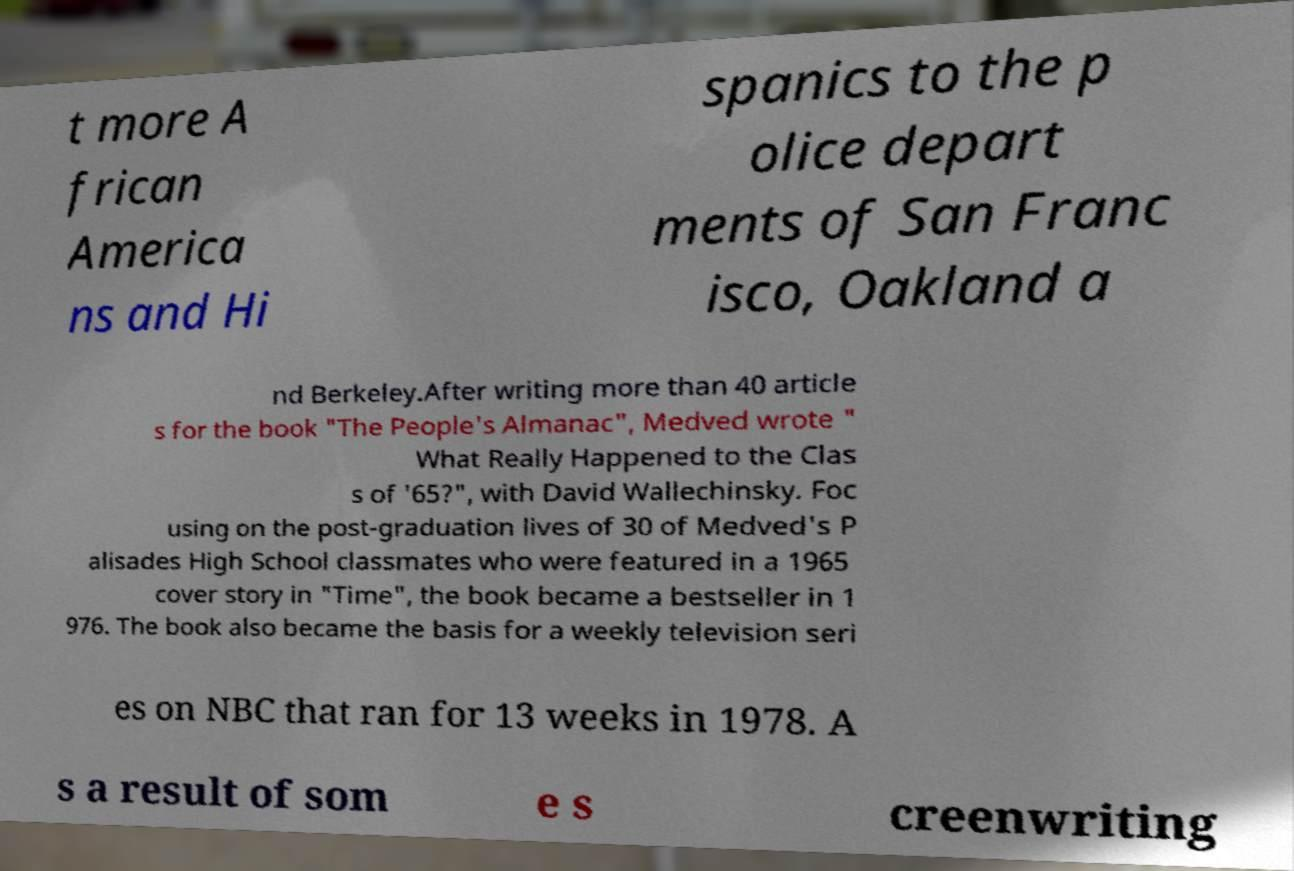Can you read and provide the text displayed in the image?This photo seems to have some interesting text. Can you extract and type it out for me? t more A frican America ns and Hi spanics to the p olice depart ments of San Franc isco, Oakland a nd Berkeley.After writing more than 40 article s for the book "The People's Almanac", Medved wrote " What Really Happened to the Clas s of '65?", with David Wallechinsky. Foc using on the post-graduation lives of 30 of Medved's P alisades High School classmates who were featured in a 1965 cover story in "Time", the book became a bestseller in 1 976. The book also became the basis for a weekly television seri es on NBC that ran for 13 weeks in 1978. A s a result of som e s creenwriting 